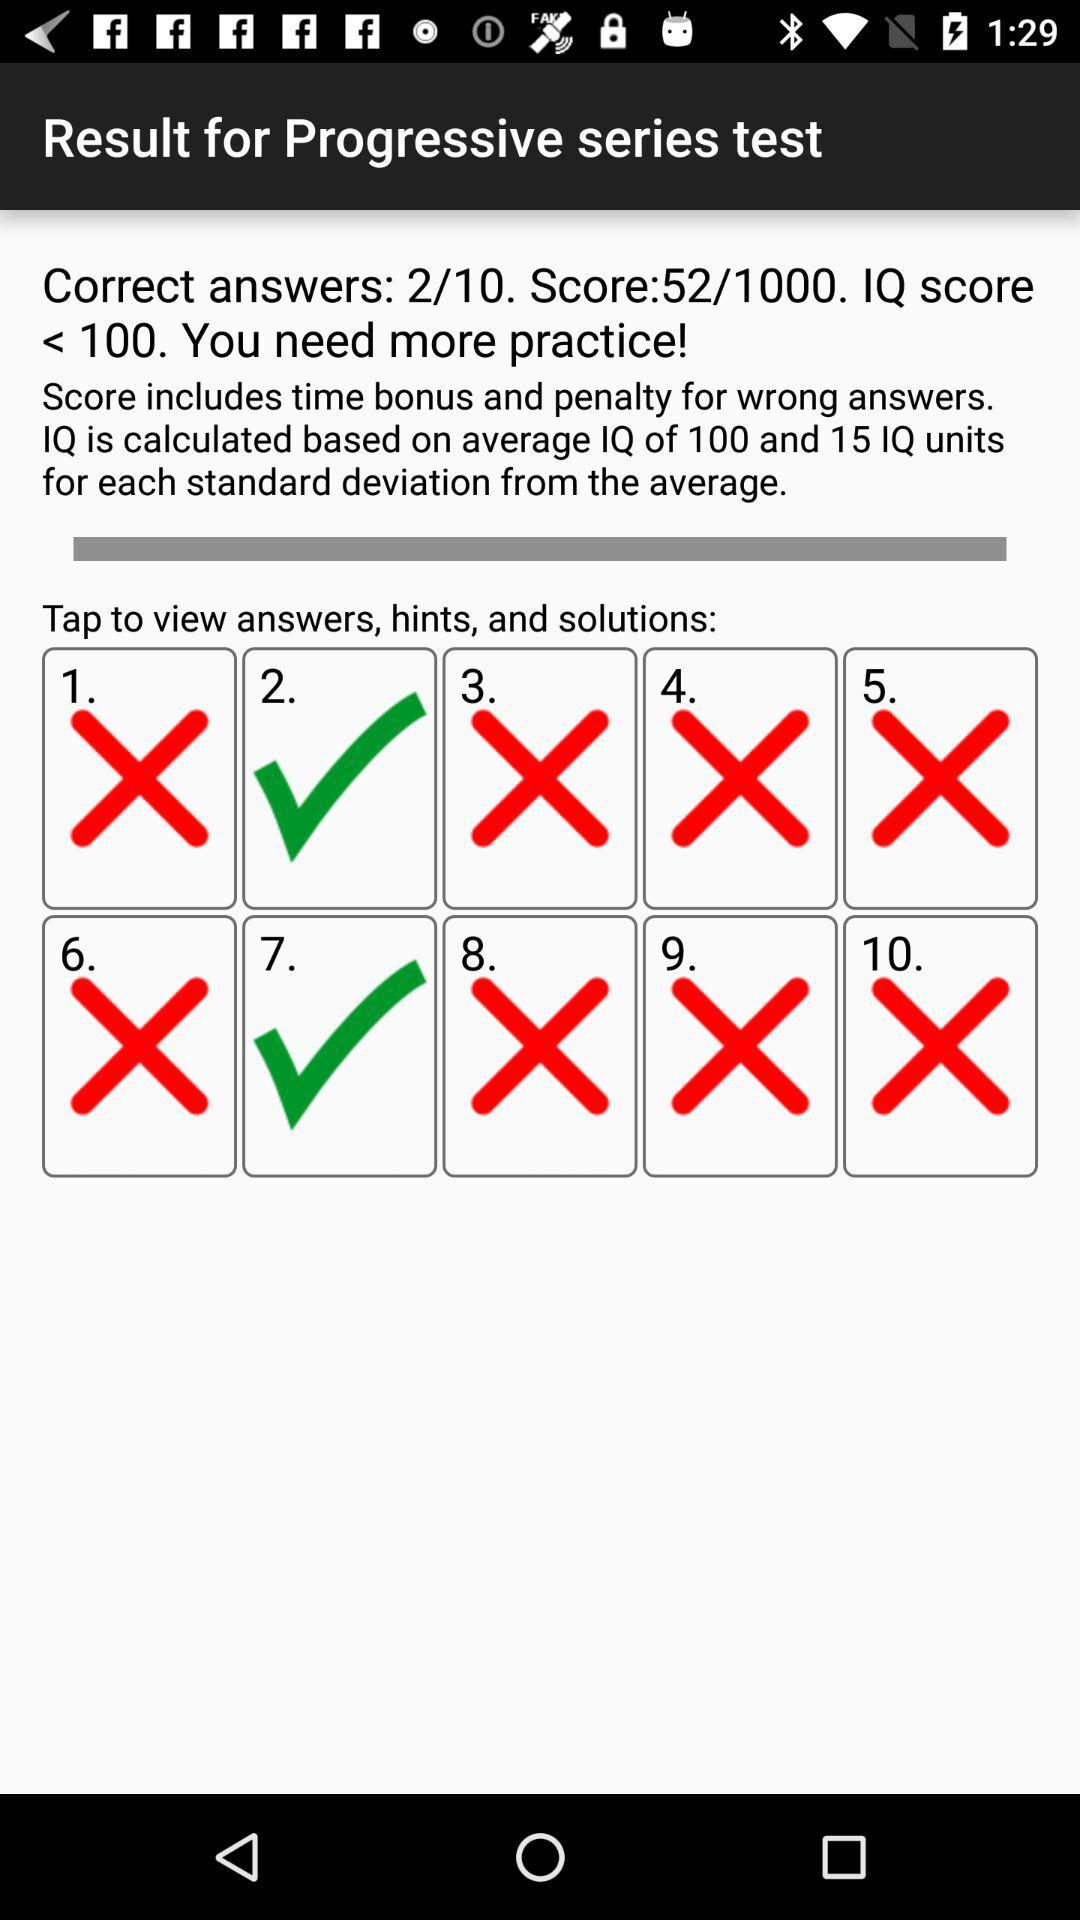What is the total number of questions? The total number of questions is 10. 